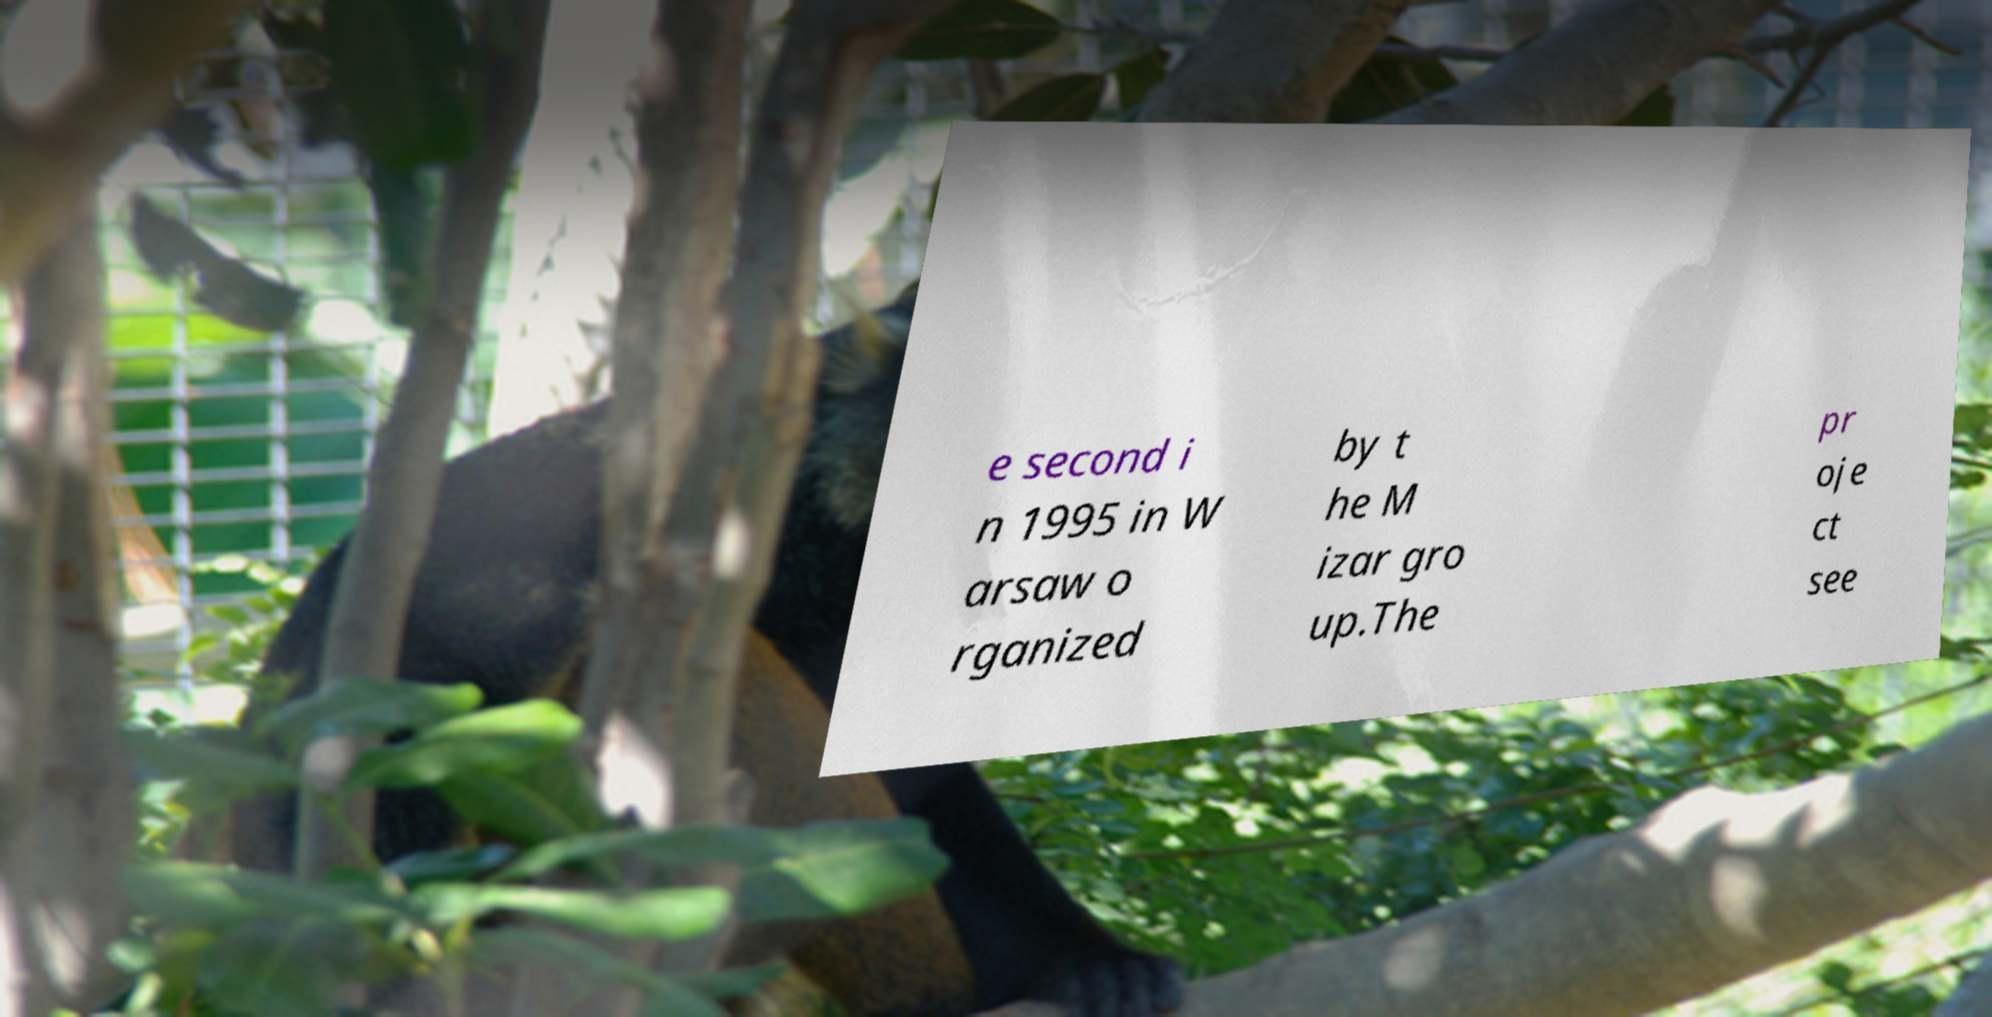Can you read and provide the text displayed in the image?This photo seems to have some interesting text. Can you extract and type it out for me? e second i n 1995 in W arsaw o rganized by t he M izar gro up.The pr oje ct see 